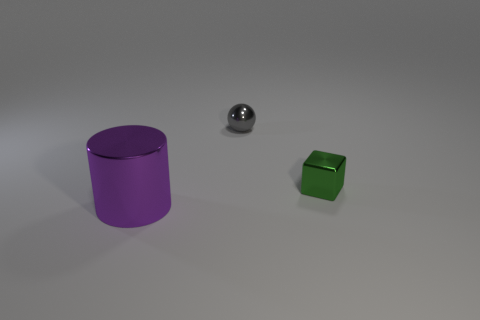Add 1 tiny green objects. How many objects exist? 4 Subtract all spheres. How many objects are left? 2 Add 3 large shiny things. How many large shiny things exist? 4 Subtract 0 yellow spheres. How many objects are left? 3 Subtract all large purple metallic cylinders. Subtract all tiny purple rubber spheres. How many objects are left? 2 Add 3 tiny things. How many tiny things are left? 5 